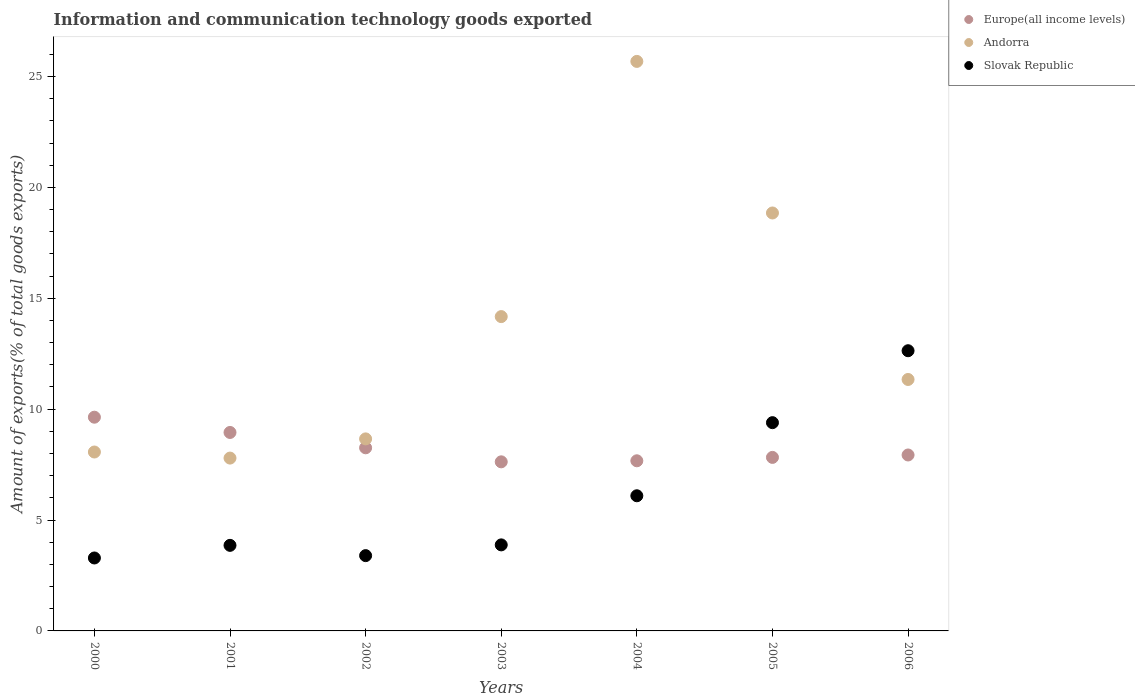Is the number of dotlines equal to the number of legend labels?
Your answer should be compact. Yes. What is the amount of goods exported in Europe(all income levels) in 2004?
Offer a very short reply. 7.67. Across all years, what is the maximum amount of goods exported in Andorra?
Offer a terse response. 25.68. Across all years, what is the minimum amount of goods exported in Slovak Republic?
Ensure brevity in your answer.  3.29. What is the total amount of goods exported in Andorra in the graph?
Your answer should be compact. 94.57. What is the difference between the amount of goods exported in Slovak Republic in 2001 and that in 2002?
Your answer should be very brief. 0.46. What is the difference between the amount of goods exported in Andorra in 2003 and the amount of goods exported in Europe(all income levels) in 2005?
Provide a short and direct response. 6.35. What is the average amount of goods exported in Andorra per year?
Make the answer very short. 13.51. In the year 2003, what is the difference between the amount of goods exported in Andorra and amount of goods exported in Slovak Republic?
Provide a short and direct response. 10.29. What is the ratio of the amount of goods exported in Andorra in 2005 to that in 2006?
Offer a terse response. 1.66. Is the amount of goods exported in Andorra in 2002 less than that in 2005?
Provide a succinct answer. Yes. What is the difference between the highest and the second highest amount of goods exported in Slovak Republic?
Your answer should be very brief. 3.24. What is the difference between the highest and the lowest amount of goods exported in Europe(all income levels)?
Give a very brief answer. 2.01. In how many years, is the amount of goods exported in Europe(all income levels) greater than the average amount of goods exported in Europe(all income levels) taken over all years?
Ensure brevity in your answer.  2. Is the sum of the amount of goods exported in Andorra in 2000 and 2001 greater than the maximum amount of goods exported in Slovak Republic across all years?
Provide a succinct answer. Yes. Is it the case that in every year, the sum of the amount of goods exported in Slovak Republic and amount of goods exported in Europe(all income levels)  is greater than the amount of goods exported in Andorra?
Your answer should be very brief. No. Does the amount of goods exported in Andorra monotonically increase over the years?
Offer a very short reply. No. How many dotlines are there?
Your answer should be compact. 3. Where does the legend appear in the graph?
Provide a succinct answer. Top right. How many legend labels are there?
Give a very brief answer. 3. How are the legend labels stacked?
Give a very brief answer. Vertical. What is the title of the graph?
Offer a terse response. Information and communication technology goods exported. Does "Oman" appear as one of the legend labels in the graph?
Give a very brief answer. No. What is the label or title of the X-axis?
Provide a short and direct response. Years. What is the label or title of the Y-axis?
Offer a very short reply. Amount of exports(% of total goods exports). What is the Amount of exports(% of total goods exports) in Europe(all income levels) in 2000?
Ensure brevity in your answer.  9.64. What is the Amount of exports(% of total goods exports) of Andorra in 2000?
Ensure brevity in your answer.  8.07. What is the Amount of exports(% of total goods exports) in Slovak Republic in 2000?
Your response must be concise. 3.29. What is the Amount of exports(% of total goods exports) in Europe(all income levels) in 2001?
Make the answer very short. 8.95. What is the Amount of exports(% of total goods exports) in Andorra in 2001?
Provide a succinct answer. 7.79. What is the Amount of exports(% of total goods exports) of Slovak Republic in 2001?
Offer a very short reply. 3.86. What is the Amount of exports(% of total goods exports) in Europe(all income levels) in 2002?
Provide a succinct answer. 8.26. What is the Amount of exports(% of total goods exports) in Andorra in 2002?
Give a very brief answer. 8.66. What is the Amount of exports(% of total goods exports) of Slovak Republic in 2002?
Make the answer very short. 3.4. What is the Amount of exports(% of total goods exports) in Europe(all income levels) in 2003?
Give a very brief answer. 7.63. What is the Amount of exports(% of total goods exports) in Andorra in 2003?
Offer a very short reply. 14.17. What is the Amount of exports(% of total goods exports) in Slovak Republic in 2003?
Offer a very short reply. 3.88. What is the Amount of exports(% of total goods exports) in Europe(all income levels) in 2004?
Your answer should be very brief. 7.67. What is the Amount of exports(% of total goods exports) of Andorra in 2004?
Provide a succinct answer. 25.68. What is the Amount of exports(% of total goods exports) of Slovak Republic in 2004?
Offer a very short reply. 6.09. What is the Amount of exports(% of total goods exports) of Europe(all income levels) in 2005?
Offer a very short reply. 7.83. What is the Amount of exports(% of total goods exports) of Andorra in 2005?
Provide a short and direct response. 18.85. What is the Amount of exports(% of total goods exports) in Slovak Republic in 2005?
Make the answer very short. 9.39. What is the Amount of exports(% of total goods exports) of Europe(all income levels) in 2006?
Your answer should be compact. 7.93. What is the Amount of exports(% of total goods exports) in Andorra in 2006?
Offer a terse response. 11.34. What is the Amount of exports(% of total goods exports) of Slovak Republic in 2006?
Offer a terse response. 12.64. Across all years, what is the maximum Amount of exports(% of total goods exports) of Europe(all income levels)?
Give a very brief answer. 9.64. Across all years, what is the maximum Amount of exports(% of total goods exports) in Andorra?
Offer a very short reply. 25.68. Across all years, what is the maximum Amount of exports(% of total goods exports) in Slovak Republic?
Offer a terse response. 12.64. Across all years, what is the minimum Amount of exports(% of total goods exports) in Europe(all income levels)?
Make the answer very short. 7.63. Across all years, what is the minimum Amount of exports(% of total goods exports) of Andorra?
Give a very brief answer. 7.79. Across all years, what is the minimum Amount of exports(% of total goods exports) of Slovak Republic?
Offer a very short reply. 3.29. What is the total Amount of exports(% of total goods exports) in Europe(all income levels) in the graph?
Your answer should be compact. 57.9. What is the total Amount of exports(% of total goods exports) of Andorra in the graph?
Give a very brief answer. 94.57. What is the total Amount of exports(% of total goods exports) of Slovak Republic in the graph?
Your answer should be very brief. 42.55. What is the difference between the Amount of exports(% of total goods exports) in Europe(all income levels) in 2000 and that in 2001?
Keep it short and to the point. 0.69. What is the difference between the Amount of exports(% of total goods exports) of Andorra in 2000 and that in 2001?
Provide a short and direct response. 0.27. What is the difference between the Amount of exports(% of total goods exports) of Slovak Republic in 2000 and that in 2001?
Offer a very short reply. -0.57. What is the difference between the Amount of exports(% of total goods exports) of Europe(all income levels) in 2000 and that in 2002?
Provide a succinct answer. 1.38. What is the difference between the Amount of exports(% of total goods exports) in Andorra in 2000 and that in 2002?
Ensure brevity in your answer.  -0.59. What is the difference between the Amount of exports(% of total goods exports) in Slovak Republic in 2000 and that in 2002?
Give a very brief answer. -0.11. What is the difference between the Amount of exports(% of total goods exports) in Europe(all income levels) in 2000 and that in 2003?
Make the answer very short. 2.01. What is the difference between the Amount of exports(% of total goods exports) of Andorra in 2000 and that in 2003?
Your response must be concise. -6.11. What is the difference between the Amount of exports(% of total goods exports) of Slovak Republic in 2000 and that in 2003?
Your answer should be compact. -0.59. What is the difference between the Amount of exports(% of total goods exports) of Europe(all income levels) in 2000 and that in 2004?
Your answer should be compact. 1.97. What is the difference between the Amount of exports(% of total goods exports) in Andorra in 2000 and that in 2004?
Offer a terse response. -17.61. What is the difference between the Amount of exports(% of total goods exports) of Slovak Republic in 2000 and that in 2004?
Provide a succinct answer. -2.81. What is the difference between the Amount of exports(% of total goods exports) in Europe(all income levels) in 2000 and that in 2005?
Your response must be concise. 1.81. What is the difference between the Amount of exports(% of total goods exports) of Andorra in 2000 and that in 2005?
Your answer should be compact. -10.78. What is the difference between the Amount of exports(% of total goods exports) of Slovak Republic in 2000 and that in 2005?
Your answer should be compact. -6.1. What is the difference between the Amount of exports(% of total goods exports) in Europe(all income levels) in 2000 and that in 2006?
Provide a succinct answer. 1.7. What is the difference between the Amount of exports(% of total goods exports) of Andorra in 2000 and that in 2006?
Provide a succinct answer. -3.27. What is the difference between the Amount of exports(% of total goods exports) in Slovak Republic in 2000 and that in 2006?
Provide a short and direct response. -9.35. What is the difference between the Amount of exports(% of total goods exports) of Europe(all income levels) in 2001 and that in 2002?
Give a very brief answer. 0.69. What is the difference between the Amount of exports(% of total goods exports) in Andorra in 2001 and that in 2002?
Offer a very short reply. -0.87. What is the difference between the Amount of exports(% of total goods exports) of Slovak Republic in 2001 and that in 2002?
Provide a succinct answer. 0.46. What is the difference between the Amount of exports(% of total goods exports) of Europe(all income levels) in 2001 and that in 2003?
Provide a succinct answer. 1.32. What is the difference between the Amount of exports(% of total goods exports) in Andorra in 2001 and that in 2003?
Ensure brevity in your answer.  -6.38. What is the difference between the Amount of exports(% of total goods exports) in Slovak Republic in 2001 and that in 2003?
Your response must be concise. -0.02. What is the difference between the Amount of exports(% of total goods exports) of Europe(all income levels) in 2001 and that in 2004?
Your response must be concise. 1.28. What is the difference between the Amount of exports(% of total goods exports) of Andorra in 2001 and that in 2004?
Give a very brief answer. -17.89. What is the difference between the Amount of exports(% of total goods exports) of Slovak Republic in 2001 and that in 2004?
Keep it short and to the point. -2.24. What is the difference between the Amount of exports(% of total goods exports) of Europe(all income levels) in 2001 and that in 2005?
Ensure brevity in your answer.  1.12. What is the difference between the Amount of exports(% of total goods exports) of Andorra in 2001 and that in 2005?
Make the answer very short. -11.05. What is the difference between the Amount of exports(% of total goods exports) in Slovak Republic in 2001 and that in 2005?
Your response must be concise. -5.53. What is the difference between the Amount of exports(% of total goods exports) of Europe(all income levels) in 2001 and that in 2006?
Your answer should be very brief. 1.02. What is the difference between the Amount of exports(% of total goods exports) in Andorra in 2001 and that in 2006?
Give a very brief answer. -3.54. What is the difference between the Amount of exports(% of total goods exports) in Slovak Republic in 2001 and that in 2006?
Offer a terse response. -8.78. What is the difference between the Amount of exports(% of total goods exports) in Europe(all income levels) in 2002 and that in 2003?
Offer a terse response. 0.63. What is the difference between the Amount of exports(% of total goods exports) of Andorra in 2002 and that in 2003?
Provide a short and direct response. -5.51. What is the difference between the Amount of exports(% of total goods exports) of Slovak Republic in 2002 and that in 2003?
Provide a short and direct response. -0.48. What is the difference between the Amount of exports(% of total goods exports) in Europe(all income levels) in 2002 and that in 2004?
Your answer should be compact. 0.59. What is the difference between the Amount of exports(% of total goods exports) in Andorra in 2002 and that in 2004?
Offer a terse response. -17.02. What is the difference between the Amount of exports(% of total goods exports) of Slovak Republic in 2002 and that in 2004?
Make the answer very short. -2.7. What is the difference between the Amount of exports(% of total goods exports) of Europe(all income levels) in 2002 and that in 2005?
Your answer should be very brief. 0.43. What is the difference between the Amount of exports(% of total goods exports) of Andorra in 2002 and that in 2005?
Offer a very short reply. -10.19. What is the difference between the Amount of exports(% of total goods exports) in Slovak Republic in 2002 and that in 2005?
Your answer should be compact. -6. What is the difference between the Amount of exports(% of total goods exports) in Europe(all income levels) in 2002 and that in 2006?
Provide a short and direct response. 0.32. What is the difference between the Amount of exports(% of total goods exports) in Andorra in 2002 and that in 2006?
Give a very brief answer. -2.68. What is the difference between the Amount of exports(% of total goods exports) in Slovak Republic in 2002 and that in 2006?
Keep it short and to the point. -9.24. What is the difference between the Amount of exports(% of total goods exports) in Europe(all income levels) in 2003 and that in 2004?
Offer a very short reply. -0.05. What is the difference between the Amount of exports(% of total goods exports) in Andorra in 2003 and that in 2004?
Your response must be concise. -11.51. What is the difference between the Amount of exports(% of total goods exports) in Slovak Republic in 2003 and that in 2004?
Offer a very short reply. -2.21. What is the difference between the Amount of exports(% of total goods exports) of Andorra in 2003 and that in 2005?
Give a very brief answer. -4.67. What is the difference between the Amount of exports(% of total goods exports) in Slovak Republic in 2003 and that in 2005?
Make the answer very short. -5.51. What is the difference between the Amount of exports(% of total goods exports) of Europe(all income levels) in 2003 and that in 2006?
Give a very brief answer. -0.31. What is the difference between the Amount of exports(% of total goods exports) in Andorra in 2003 and that in 2006?
Provide a short and direct response. 2.84. What is the difference between the Amount of exports(% of total goods exports) in Slovak Republic in 2003 and that in 2006?
Provide a succinct answer. -8.76. What is the difference between the Amount of exports(% of total goods exports) of Europe(all income levels) in 2004 and that in 2005?
Offer a very short reply. -0.15. What is the difference between the Amount of exports(% of total goods exports) of Andorra in 2004 and that in 2005?
Keep it short and to the point. 6.83. What is the difference between the Amount of exports(% of total goods exports) in Slovak Republic in 2004 and that in 2005?
Keep it short and to the point. -3.3. What is the difference between the Amount of exports(% of total goods exports) of Europe(all income levels) in 2004 and that in 2006?
Provide a succinct answer. -0.26. What is the difference between the Amount of exports(% of total goods exports) of Andorra in 2004 and that in 2006?
Provide a succinct answer. 14.34. What is the difference between the Amount of exports(% of total goods exports) in Slovak Republic in 2004 and that in 2006?
Offer a terse response. -6.54. What is the difference between the Amount of exports(% of total goods exports) of Europe(all income levels) in 2005 and that in 2006?
Keep it short and to the point. -0.11. What is the difference between the Amount of exports(% of total goods exports) of Andorra in 2005 and that in 2006?
Give a very brief answer. 7.51. What is the difference between the Amount of exports(% of total goods exports) of Slovak Republic in 2005 and that in 2006?
Make the answer very short. -3.24. What is the difference between the Amount of exports(% of total goods exports) of Europe(all income levels) in 2000 and the Amount of exports(% of total goods exports) of Andorra in 2001?
Provide a short and direct response. 1.84. What is the difference between the Amount of exports(% of total goods exports) in Europe(all income levels) in 2000 and the Amount of exports(% of total goods exports) in Slovak Republic in 2001?
Offer a terse response. 5.78. What is the difference between the Amount of exports(% of total goods exports) in Andorra in 2000 and the Amount of exports(% of total goods exports) in Slovak Republic in 2001?
Your answer should be very brief. 4.21. What is the difference between the Amount of exports(% of total goods exports) in Europe(all income levels) in 2000 and the Amount of exports(% of total goods exports) in Andorra in 2002?
Ensure brevity in your answer.  0.98. What is the difference between the Amount of exports(% of total goods exports) in Europe(all income levels) in 2000 and the Amount of exports(% of total goods exports) in Slovak Republic in 2002?
Provide a short and direct response. 6.24. What is the difference between the Amount of exports(% of total goods exports) in Andorra in 2000 and the Amount of exports(% of total goods exports) in Slovak Republic in 2002?
Your response must be concise. 4.67. What is the difference between the Amount of exports(% of total goods exports) of Europe(all income levels) in 2000 and the Amount of exports(% of total goods exports) of Andorra in 2003?
Ensure brevity in your answer.  -4.54. What is the difference between the Amount of exports(% of total goods exports) in Europe(all income levels) in 2000 and the Amount of exports(% of total goods exports) in Slovak Republic in 2003?
Provide a short and direct response. 5.76. What is the difference between the Amount of exports(% of total goods exports) in Andorra in 2000 and the Amount of exports(% of total goods exports) in Slovak Republic in 2003?
Make the answer very short. 4.19. What is the difference between the Amount of exports(% of total goods exports) of Europe(all income levels) in 2000 and the Amount of exports(% of total goods exports) of Andorra in 2004?
Give a very brief answer. -16.04. What is the difference between the Amount of exports(% of total goods exports) of Europe(all income levels) in 2000 and the Amount of exports(% of total goods exports) of Slovak Republic in 2004?
Make the answer very short. 3.54. What is the difference between the Amount of exports(% of total goods exports) in Andorra in 2000 and the Amount of exports(% of total goods exports) in Slovak Republic in 2004?
Your answer should be compact. 1.97. What is the difference between the Amount of exports(% of total goods exports) in Europe(all income levels) in 2000 and the Amount of exports(% of total goods exports) in Andorra in 2005?
Give a very brief answer. -9.21. What is the difference between the Amount of exports(% of total goods exports) in Europe(all income levels) in 2000 and the Amount of exports(% of total goods exports) in Slovak Republic in 2005?
Give a very brief answer. 0.25. What is the difference between the Amount of exports(% of total goods exports) of Andorra in 2000 and the Amount of exports(% of total goods exports) of Slovak Republic in 2005?
Offer a very short reply. -1.32. What is the difference between the Amount of exports(% of total goods exports) in Europe(all income levels) in 2000 and the Amount of exports(% of total goods exports) in Andorra in 2006?
Keep it short and to the point. -1.7. What is the difference between the Amount of exports(% of total goods exports) of Europe(all income levels) in 2000 and the Amount of exports(% of total goods exports) of Slovak Republic in 2006?
Your answer should be compact. -3. What is the difference between the Amount of exports(% of total goods exports) in Andorra in 2000 and the Amount of exports(% of total goods exports) in Slovak Republic in 2006?
Your answer should be compact. -4.57. What is the difference between the Amount of exports(% of total goods exports) of Europe(all income levels) in 2001 and the Amount of exports(% of total goods exports) of Andorra in 2002?
Ensure brevity in your answer.  0.29. What is the difference between the Amount of exports(% of total goods exports) in Europe(all income levels) in 2001 and the Amount of exports(% of total goods exports) in Slovak Republic in 2002?
Offer a very short reply. 5.55. What is the difference between the Amount of exports(% of total goods exports) in Andorra in 2001 and the Amount of exports(% of total goods exports) in Slovak Republic in 2002?
Your answer should be very brief. 4.4. What is the difference between the Amount of exports(% of total goods exports) in Europe(all income levels) in 2001 and the Amount of exports(% of total goods exports) in Andorra in 2003?
Your answer should be compact. -5.22. What is the difference between the Amount of exports(% of total goods exports) in Europe(all income levels) in 2001 and the Amount of exports(% of total goods exports) in Slovak Republic in 2003?
Keep it short and to the point. 5.07. What is the difference between the Amount of exports(% of total goods exports) in Andorra in 2001 and the Amount of exports(% of total goods exports) in Slovak Republic in 2003?
Offer a terse response. 3.91. What is the difference between the Amount of exports(% of total goods exports) of Europe(all income levels) in 2001 and the Amount of exports(% of total goods exports) of Andorra in 2004?
Your answer should be compact. -16.73. What is the difference between the Amount of exports(% of total goods exports) of Europe(all income levels) in 2001 and the Amount of exports(% of total goods exports) of Slovak Republic in 2004?
Offer a very short reply. 2.85. What is the difference between the Amount of exports(% of total goods exports) of Andorra in 2001 and the Amount of exports(% of total goods exports) of Slovak Republic in 2004?
Provide a succinct answer. 1.7. What is the difference between the Amount of exports(% of total goods exports) in Europe(all income levels) in 2001 and the Amount of exports(% of total goods exports) in Andorra in 2005?
Give a very brief answer. -9.9. What is the difference between the Amount of exports(% of total goods exports) of Europe(all income levels) in 2001 and the Amount of exports(% of total goods exports) of Slovak Republic in 2005?
Your response must be concise. -0.44. What is the difference between the Amount of exports(% of total goods exports) in Andorra in 2001 and the Amount of exports(% of total goods exports) in Slovak Republic in 2005?
Make the answer very short. -1.6. What is the difference between the Amount of exports(% of total goods exports) in Europe(all income levels) in 2001 and the Amount of exports(% of total goods exports) in Andorra in 2006?
Your answer should be very brief. -2.39. What is the difference between the Amount of exports(% of total goods exports) of Europe(all income levels) in 2001 and the Amount of exports(% of total goods exports) of Slovak Republic in 2006?
Provide a short and direct response. -3.69. What is the difference between the Amount of exports(% of total goods exports) in Andorra in 2001 and the Amount of exports(% of total goods exports) in Slovak Republic in 2006?
Ensure brevity in your answer.  -4.84. What is the difference between the Amount of exports(% of total goods exports) of Europe(all income levels) in 2002 and the Amount of exports(% of total goods exports) of Andorra in 2003?
Give a very brief answer. -5.92. What is the difference between the Amount of exports(% of total goods exports) in Europe(all income levels) in 2002 and the Amount of exports(% of total goods exports) in Slovak Republic in 2003?
Ensure brevity in your answer.  4.38. What is the difference between the Amount of exports(% of total goods exports) of Andorra in 2002 and the Amount of exports(% of total goods exports) of Slovak Republic in 2003?
Your answer should be very brief. 4.78. What is the difference between the Amount of exports(% of total goods exports) in Europe(all income levels) in 2002 and the Amount of exports(% of total goods exports) in Andorra in 2004?
Your response must be concise. -17.43. What is the difference between the Amount of exports(% of total goods exports) in Europe(all income levels) in 2002 and the Amount of exports(% of total goods exports) in Slovak Republic in 2004?
Provide a succinct answer. 2.16. What is the difference between the Amount of exports(% of total goods exports) of Andorra in 2002 and the Amount of exports(% of total goods exports) of Slovak Republic in 2004?
Provide a short and direct response. 2.56. What is the difference between the Amount of exports(% of total goods exports) of Europe(all income levels) in 2002 and the Amount of exports(% of total goods exports) of Andorra in 2005?
Your answer should be very brief. -10.59. What is the difference between the Amount of exports(% of total goods exports) in Europe(all income levels) in 2002 and the Amount of exports(% of total goods exports) in Slovak Republic in 2005?
Provide a succinct answer. -1.13. What is the difference between the Amount of exports(% of total goods exports) in Andorra in 2002 and the Amount of exports(% of total goods exports) in Slovak Republic in 2005?
Offer a very short reply. -0.73. What is the difference between the Amount of exports(% of total goods exports) of Europe(all income levels) in 2002 and the Amount of exports(% of total goods exports) of Andorra in 2006?
Your answer should be compact. -3.08. What is the difference between the Amount of exports(% of total goods exports) in Europe(all income levels) in 2002 and the Amount of exports(% of total goods exports) in Slovak Republic in 2006?
Offer a very short reply. -4.38. What is the difference between the Amount of exports(% of total goods exports) of Andorra in 2002 and the Amount of exports(% of total goods exports) of Slovak Republic in 2006?
Offer a terse response. -3.98. What is the difference between the Amount of exports(% of total goods exports) in Europe(all income levels) in 2003 and the Amount of exports(% of total goods exports) in Andorra in 2004?
Make the answer very short. -18.06. What is the difference between the Amount of exports(% of total goods exports) in Europe(all income levels) in 2003 and the Amount of exports(% of total goods exports) in Slovak Republic in 2004?
Offer a terse response. 1.53. What is the difference between the Amount of exports(% of total goods exports) in Andorra in 2003 and the Amount of exports(% of total goods exports) in Slovak Republic in 2004?
Provide a short and direct response. 8.08. What is the difference between the Amount of exports(% of total goods exports) in Europe(all income levels) in 2003 and the Amount of exports(% of total goods exports) in Andorra in 2005?
Give a very brief answer. -11.22. What is the difference between the Amount of exports(% of total goods exports) of Europe(all income levels) in 2003 and the Amount of exports(% of total goods exports) of Slovak Republic in 2005?
Your answer should be compact. -1.77. What is the difference between the Amount of exports(% of total goods exports) of Andorra in 2003 and the Amount of exports(% of total goods exports) of Slovak Republic in 2005?
Your response must be concise. 4.78. What is the difference between the Amount of exports(% of total goods exports) in Europe(all income levels) in 2003 and the Amount of exports(% of total goods exports) in Andorra in 2006?
Give a very brief answer. -3.71. What is the difference between the Amount of exports(% of total goods exports) of Europe(all income levels) in 2003 and the Amount of exports(% of total goods exports) of Slovak Republic in 2006?
Offer a very short reply. -5.01. What is the difference between the Amount of exports(% of total goods exports) in Andorra in 2003 and the Amount of exports(% of total goods exports) in Slovak Republic in 2006?
Make the answer very short. 1.54. What is the difference between the Amount of exports(% of total goods exports) of Europe(all income levels) in 2004 and the Amount of exports(% of total goods exports) of Andorra in 2005?
Offer a terse response. -11.18. What is the difference between the Amount of exports(% of total goods exports) in Europe(all income levels) in 2004 and the Amount of exports(% of total goods exports) in Slovak Republic in 2005?
Keep it short and to the point. -1.72. What is the difference between the Amount of exports(% of total goods exports) of Andorra in 2004 and the Amount of exports(% of total goods exports) of Slovak Republic in 2005?
Give a very brief answer. 16.29. What is the difference between the Amount of exports(% of total goods exports) in Europe(all income levels) in 2004 and the Amount of exports(% of total goods exports) in Andorra in 2006?
Offer a very short reply. -3.67. What is the difference between the Amount of exports(% of total goods exports) of Europe(all income levels) in 2004 and the Amount of exports(% of total goods exports) of Slovak Republic in 2006?
Keep it short and to the point. -4.96. What is the difference between the Amount of exports(% of total goods exports) in Andorra in 2004 and the Amount of exports(% of total goods exports) in Slovak Republic in 2006?
Ensure brevity in your answer.  13.05. What is the difference between the Amount of exports(% of total goods exports) of Europe(all income levels) in 2005 and the Amount of exports(% of total goods exports) of Andorra in 2006?
Keep it short and to the point. -3.51. What is the difference between the Amount of exports(% of total goods exports) of Europe(all income levels) in 2005 and the Amount of exports(% of total goods exports) of Slovak Republic in 2006?
Provide a short and direct response. -4.81. What is the difference between the Amount of exports(% of total goods exports) in Andorra in 2005 and the Amount of exports(% of total goods exports) in Slovak Republic in 2006?
Give a very brief answer. 6.21. What is the average Amount of exports(% of total goods exports) of Europe(all income levels) per year?
Offer a very short reply. 8.27. What is the average Amount of exports(% of total goods exports) of Andorra per year?
Offer a very short reply. 13.51. What is the average Amount of exports(% of total goods exports) of Slovak Republic per year?
Make the answer very short. 6.08. In the year 2000, what is the difference between the Amount of exports(% of total goods exports) of Europe(all income levels) and Amount of exports(% of total goods exports) of Andorra?
Give a very brief answer. 1.57. In the year 2000, what is the difference between the Amount of exports(% of total goods exports) in Europe(all income levels) and Amount of exports(% of total goods exports) in Slovak Republic?
Ensure brevity in your answer.  6.35. In the year 2000, what is the difference between the Amount of exports(% of total goods exports) in Andorra and Amount of exports(% of total goods exports) in Slovak Republic?
Provide a succinct answer. 4.78. In the year 2001, what is the difference between the Amount of exports(% of total goods exports) of Europe(all income levels) and Amount of exports(% of total goods exports) of Andorra?
Ensure brevity in your answer.  1.16. In the year 2001, what is the difference between the Amount of exports(% of total goods exports) in Europe(all income levels) and Amount of exports(% of total goods exports) in Slovak Republic?
Your answer should be compact. 5.09. In the year 2001, what is the difference between the Amount of exports(% of total goods exports) of Andorra and Amount of exports(% of total goods exports) of Slovak Republic?
Your answer should be very brief. 3.94. In the year 2002, what is the difference between the Amount of exports(% of total goods exports) in Europe(all income levels) and Amount of exports(% of total goods exports) in Andorra?
Your answer should be very brief. -0.4. In the year 2002, what is the difference between the Amount of exports(% of total goods exports) in Europe(all income levels) and Amount of exports(% of total goods exports) in Slovak Republic?
Offer a very short reply. 4.86. In the year 2002, what is the difference between the Amount of exports(% of total goods exports) of Andorra and Amount of exports(% of total goods exports) of Slovak Republic?
Provide a succinct answer. 5.26. In the year 2003, what is the difference between the Amount of exports(% of total goods exports) in Europe(all income levels) and Amount of exports(% of total goods exports) in Andorra?
Your response must be concise. -6.55. In the year 2003, what is the difference between the Amount of exports(% of total goods exports) in Europe(all income levels) and Amount of exports(% of total goods exports) in Slovak Republic?
Provide a short and direct response. 3.75. In the year 2003, what is the difference between the Amount of exports(% of total goods exports) of Andorra and Amount of exports(% of total goods exports) of Slovak Republic?
Make the answer very short. 10.29. In the year 2004, what is the difference between the Amount of exports(% of total goods exports) of Europe(all income levels) and Amount of exports(% of total goods exports) of Andorra?
Offer a terse response. -18.01. In the year 2004, what is the difference between the Amount of exports(% of total goods exports) in Europe(all income levels) and Amount of exports(% of total goods exports) in Slovak Republic?
Give a very brief answer. 1.58. In the year 2004, what is the difference between the Amount of exports(% of total goods exports) in Andorra and Amount of exports(% of total goods exports) in Slovak Republic?
Your answer should be very brief. 19.59. In the year 2005, what is the difference between the Amount of exports(% of total goods exports) of Europe(all income levels) and Amount of exports(% of total goods exports) of Andorra?
Make the answer very short. -11.02. In the year 2005, what is the difference between the Amount of exports(% of total goods exports) of Europe(all income levels) and Amount of exports(% of total goods exports) of Slovak Republic?
Offer a very short reply. -1.57. In the year 2005, what is the difference between the Amount of exports(% of total goods exports) in Andorra and Amount of exports(% of total goods exports) in Slovak Republic?
Make the answer very short. 9.46. In the year 2006, what is the difference between the Amount of exports(% of total goods exports) of Europe(all income levels) and Amount of exports(% of total goods exports) of Andorra?
Give a very brief answer. -3.4. In the year 2006, what is the difference between the Amount of exports(% of total goods exports) in Europe(all income levels) and Amount of exports(% of total goods exports) in Slovak Republic?
Ensure brevity in your answer.  -4.7. In the year 2006, what is the difference between the Amount of exports(% of total goods exports) in Andorra and Amount of exports(% of total goods exports) in Slovak Republic?
Keep it short and to the point. -1.3. What is the ratio of the Amount of exports(% of total goods exports) in Europe(all income levels) in 2000 to that in 2001?
Provide a short and direct response. 1.08. What is the ratio of the Amount of exports(% of total goods exports) in Andorra in 2000 to that in 2001?
Provide a succinct answer. 1.04. What is the ratio of the Amount of exports(% of total goods exports) in Slovak Republic in 2000 to that in 2001?
Give a very brief answer. 0.85. What is the ratio of the Amount of exports(% of total goods exports) of Europe(all income levels) in 2000 to that in 2002?
Offer a very short reply. 1.17. What is the ratio of the Amount of exports(% of total goods exports) of Andorra in 2000 to that in 2002?
Keep it short and to the point. 0.93. What is the ratio of the Amount of exports(% of total goods exports) of Slovak Republic in 2000 to that in 2002?
Your response must be concise. 0.97. What is the ratio of the Amount of exports(% of total goods exports) in Europe(all income levels) in 2000 to that in 2003?
Your answer should be compact. 1.26. What is the ratio of the Amount of exports(% of total goods exports) of Andorra in 2000 to that in 2003?
Provide a succinct answer. 0.57. What is the ratio of the Amount of exports(% of total goods exports) in Slovak Republic in 2000 to that in 2003?
Your response must be concise. 0.85. What is the ratio of the Amount of exports(% of total goods exports) in Europe(all income levels) in 2000 to that in 2004?
Your answer should be compact. 1.26. What is the ratio of the Amount of exports(% of total goods exports) of Andorra in 2000 to that in 2004?
Give a very brief answer. 0.31. What is the ratio of the Amount of exports(% of total goods exports) in Slovak Republic in 2000 to that in 2004?
Provide a short and direct response. 0.54. What is the ratio of the Amount of exports(% of total goods exports) of Europe(all income levels) in 2000 to that in 2005?
Your answer should be very brief. 1.23. What is the ratio of the Amount of exports(% of total goods exports) of Andorra in 2000 to that in 2005?
Your answer should be very brief. 0.43. What is the ratio of the Amount of exports(% of total goods exports) of Slovak Republic in 2000 to that in 2005?
Offer a very short reply. 0.35. What is the ratio of the Amount of exports(% of total goods exports) in Europe(all income levels) in 2000 to that in 2006?
Your answer should be compact. 1.21. What is the ratio of the Amount of exports(% of total goods exports) of Andorra in 2000 to that in 2006?
Make the answer very short. 0.71. What is the ratio of the Amount of exports(% of total goods exports) of Slovak Republic in 2000 to that in 2006?
Offer a terse response. 0.26. What is the ratio of the Amount of exports(% of total goods exports) in Europe(all income levels) in 2001 to that in 2002?
Offer a very short reply. 1.08. What is the ratio of the Amount of exports(% of total goods exports) in Andorra in 2001 to that in 2002?
Ensure brevity in your answer.  0.9. What is the ratio of the Amount of exports(% of total goods exports) of Slovak Republic in 2001 to that in 2002?
Your response must be concise. 1.14. What is the ratio of the Amount of exports(% of total goods exports) in Europe(all income levels) in 2001 to that in 2003?
Your answer should be compact. 1.17. What is the ratio of the Amount of exports(% of total goods exports) of Andorra in 2001 to that in 2003?
Give a very brief answer. 0.55. What is the ratio of the Amount of exports(% of total goods exports) of Europe(all income levels) in 2001 to that in 2004?
Offer a terse response. 1.17. What is the ratio of the Amount of exports(% of total goods exports) of Andorra in 2001 to that in 2004?
Ensure brevity in your answer.  0.3. What is the ratio of the Amount of exports(% of total goods exports) in Slovak Republic in 2001 to that in 2004?
Your answer should be very brief. 0.63. What is the ratio of the Amount of exports(% of total goods exports) in Europe(all income levels) in 2001 to that in 2005?
Keep it short and to the point. 1.14. What is the ratio of the Amount of exports(% of total goods exports) in Andorra in 2001 to that in 2005?
Your response must be concise. 0.41. What is the ratio of the Amount of exports(% of total goods exports) in Slovak Republic in 2001 to that in 2005?
Offer a terse response. 0.41. What is the ratio of the Amount of exports(% of total goods exports) of Europe(all income levels) in 2001 to that in 2006?
Your answer should be very brief. 1.13. What is the ratio of the Amount of exports(% of total goods exports) in Andorra in 2001 to that in 2006?
Keep it short and to the point. 0.69. What is the ratio of the Amount of exports(% of total goods exports) of Slovak Republic in 2001 to that in 2006?
Your response must be concise. 0.31. What is the ratio of the Amount of exports(% of total goods exports) in Europe(all income levels) in 2002 to that in 2003?
Give a very brief answer. 1.08. What is the ratio of the Amount of exports(% of total goods exports) in Andorra in 2002 to that in 2003?
Offer a very short reply. 0.61. What is the ratio of the Amount of exports(% of total goods exports) in Slovak Republic in 2002 to that in 2003?
Keep it short and to the point. 0.88. What is the ratio of the Amount of exports(% of total goods exports) of Europe(all income levels) in 2002 to that in 2004?
Your answer should be very brief. 1.08. What is the ratio of the Amount of exports(% of total goods exports) in Andorra in 2002 to that in 2004?
Provide a short and direct response. 0.34. What is the ratio of the Amount of exports(% of total goods exports) of Slovak Republic in 2002 to that in 2004?
Keep it short and to the point. 0.56. What is the ratio of the Amount of exports(% of total goods exports) in Europe(all income levels) in 2002 to that in 2005?
Offer a very short reply. 1.06. What is the ratio of the Amount of exports(% of total goods exports) in Andorra in 2002 to that in 2005?
Give a very brief answer. 0.46. What is the ratio of the Amount of exports(% of total goods exports) in Slovak Republic in 2002 to that in 2005?
Make the answer very short. 0.36. What is the ratio of the Amount of exports(% of total goods exports) in Europe(all income levels) in 2002 to that in 2006?
Offer a terse response. 1.04. What is the ratio of the Amount of exports(% of total goods exports) of Andorra in 2002 to that in 2006?
Keep it short and to the point. 0.76. What is the ratio of the Amount of exports(% of total goods exports) of Slovak Republic in 2002 to that in 2006?
Your answer should be compact. 0.27. What is the ratio of the Amount of exports(% of total goods exports) of Andorra in 2003 to that in 2004?
Give a very brief answer. 0.55. What is the ratio of the Amount of exports(% of total goods exports) of Slovak Republic in 2003 to that in 2004?
Your answer should be compact. 0.64. What is the ratio of the Amount of exports(% of total goods exports) of Europe(all income levels) in 2003 to that in 2005?
Your response must be concise. 0.97. What is the ratio of the Amount of exports(% of total goods exports) in Andorra in 2003 to that in 2005?
Offer a terse response. 0.75. What is the ratio of the Amount of exports(% of total goods exports) of Slovak Republic in 2003 to that in 2005?
Make the answer very short. 0.41. What is the ratio of the Amount of exports(% of total goods exports) of Europe(all income levels) in 2003 to that in 2006?
Your response must be concise. 0.96. What is the ratio of the Amount of exports(% of total goods exports) in Andorra in 2003 to that in 2006?
Provide a succinct answer. 1.25. What is the ratio of the Amount of exports(% of total goods exports) of Slovak Republic in 2003 to that in 2006?
Your answer should be very brief. 0.31. What is the ratio of the Amount of exports(% of total goods exports) of Europe(all income levels) in 2004 to that in 2005?
Your response must be concise. 0.98. What is the ratio of the Amount of exports(% of total goods exports) of Andorra in 2004 to that in 2005?
Your answer should be very brief. 1.36. What is the ratio of the Amount of exports(% of total goods exports) in Slovak Republic in 2004 to that in 2005?
Offer a very short reply. 0.65. What is the ratio of the Amount of exports(% of total goods exports) of Europe(all income levels) in 2004 to that in 2006?
Offer a very short reply. 0.97. What is the ratio of the Amount of exports(% of total goods exports) in Andorra in 2004 to that in 2006?
Your answer should be compact. 2.26. What is the ratio of the Amount of exports(% of total goods exports) of Slovak Republic in 2004 to that in 2006?
Your answer should be very brief. 0.48. What is the ratio of the Amount of exports(% of total goods exports) of Europe(all income levels) in 2005 to that in 2006?
Keep it short and to the point. 0.99. What is the ratio of the Amount of exports(% of total goods exports) in Andorra in 2005 to that in 2006?
Offer a terse response. 1.66. What is the ratio of the Amount of exports(% of total goods exports) of Slovak Republic in 2005 to that in 2006?
Ensure brevity in your answer.  0.74. What is the difference between the highest and the second highest Amount of exports(% of total goods exports) in Europe(all income levels)?
Provide a short and direct response. 0.69. What is the difference between the highest and the second highest Amount of exports(% of total goods exports) of Andorra?
Offer a terse response. 6.83. What is the difference between the highest and the second highest Amount of exports(% of total goods exports) in Slovak Republic?
Provide a succinct answer. 3.24. What is the difference between the highest and the lowest Amount of exports(% of total goods exports) of Europe(all income levels)?
Offer a terse response. 2.01. What is the difference between the highest and the lowest Amount of exports(% of total goods exports) in Andorra?
Give a very brief answer. 17.89. What is the difference between the highest and the lowest Amount of exports(% of total goods exports) of Slovak Republic?
Provide a short and direct response. 9.35. 